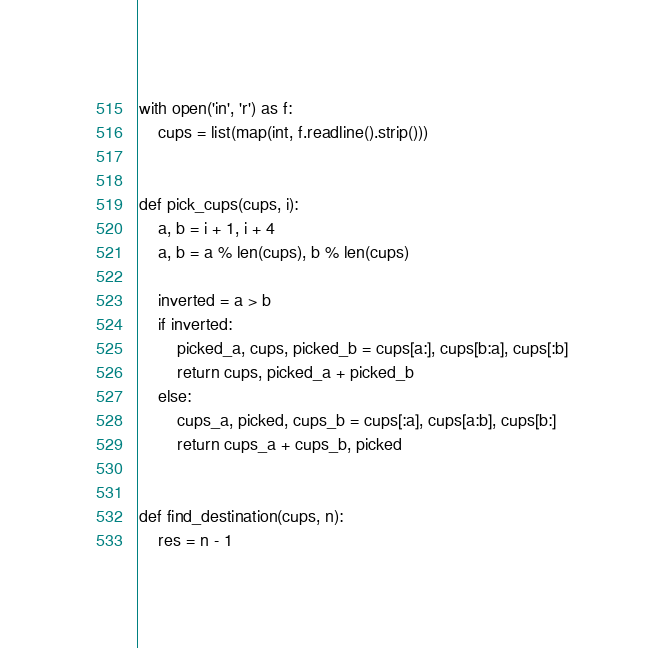<code> <loc_0><loc_0><loc_500><loc_500><_Python_>with open('in', 'r') as f:
    cups = list(map(int, f.readline().strip()))


def pick_cups(cups, i):
    a, b = i + 1, i + 4
    a, b = a % len(cups), b % len(cups)

    inverted = a > b
    if inverted:
        picked_a, cups, picked_b = cups[a:], cups[b:a], cups[:b]
        return cups, picked_a + picked_b
    else:
        cups_a, picked, cups_b = cups[:a], cups[a:b], cups[b:]
        return cups_a + cups_b, picked


def find_destination(cups, n):
    res = n - 1</code> 